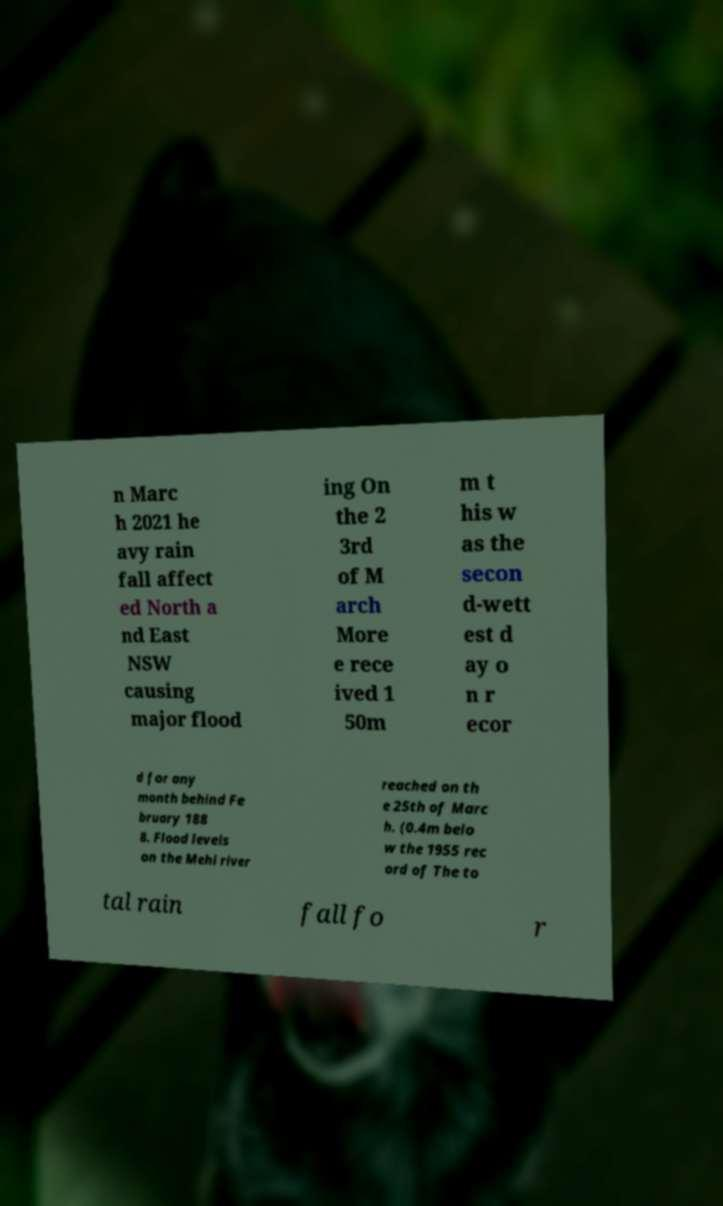Please identify and transcribe the text found in this image. n Marc h 2021 he avy rain fall affect ed North a nd East NSW causing major flood ing On the 2 3rd of M arch More e rece ived 1 50m m t his w as the secon d-wett est d ay o n r ecor d for any month behind Fe bruary 188 8. Flood levels on the Mehi river reached on th e 25th of Marc h. (0.4m belo w the 1955 rec ord of The to tal rain fall fo r 